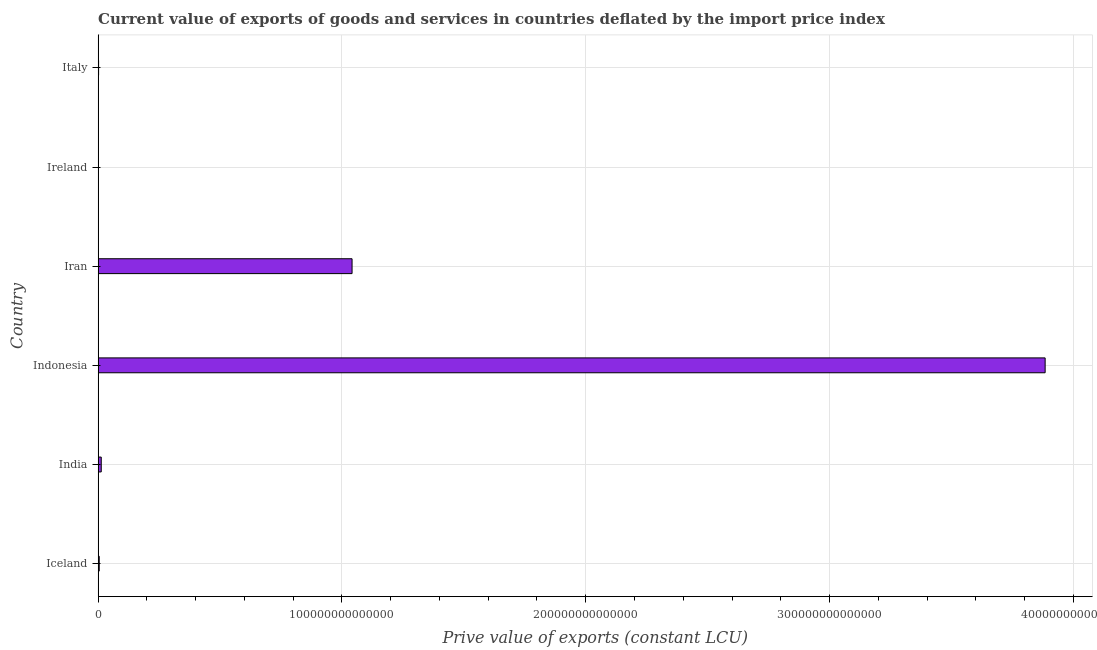What is the title of the graph?
Your answer should be compact. Current value of exports of goods and services in countries deflated by the import price index. What is the label or title of the X-axis?
Keep it short and to the point. Prive value of exports (constant LCU). What is the label or title of the Y-axis?
Your answer should be compact. Country. What is the price value of exports in Italy?
Offer a terse response. 1.94e+11. Across all countries, what is the maximum price value of exports?
Keep it short and to the point. 3.88e+14. Across all countries, what is the minimum price value of exports?
Keep it short and to the point. 2.44e+1. In which country was the price value of exports maximum?
Provide a succinct answer. Indonesia. In which country was the price value of exports minimum?
Keep it short and to the point. Ireland. What is the sum of the price value of exports?
Offer a very short reply. 4.95e+14. What is the difference between the price value of exports in Indonesia and Ireland?
Keep it short and to the point. 3.88e+14. What is the average price value of exports per country?
Make the answer very short. 8.24e+13. What is the median price value of exports?
Provide a succinct answer. 8.71e+11. In how many countries, is the price value of exports greater than 80000000000000 LCU?
Provide a short and direct response. 2. What is the ratio of the price value of exports in Iceland to that in Italy?
Your answer should be very brief. 2.36. Is the difference between the price value of exports in India and Ireland greater than the difference between any two countries?
Provide a succinct answer. No. What is the difference between the highest and the second highest price value of exports?
Make the answer very short. 2.84e+14. What is the difference between the highest and the lowest price value of exports?
Your response must be concise. 3.88e+14. In how many countries, is the price value of exports greater than the average price value of exports taken over all countries?
Provide a short and direct response. 2. How many countries are there in the graph?
Your answer should be compact. 6. What is the difference between two consecutive major ticks on the X-axis?
Your answer should be very brief. 1.00e+14. What is the Prive value of exports (constant LCU) in Iceland?
Give a very brief answer. 4.57e+11. What is the Prive value of exports (constant LCU) of India?
Give a very brief answer. 1.28e+12. What is the Prive value of exports (constant LCU) of Indonesia?
Ensure brevity in your answer.  3.88e+14. What is the Prive value of exports (constant LCU) in Iran?
Ensure brevity in your answer.  1.04e+14. What is the Prive value of exports (constant LCU) in Ireland?
Provide a short and direct response. 2.44e+1. What is the Prive value of exports (constant LCU) in Italy?
Offer a terse response. 1.94e+11. What is the difference between the Prive value of exports (constant LCU) in Iceland and India?
Provide a succinct answer. -8.27e+11. What is the difference between the Prive value of exports (constant LCU) in Iceland and Indonesia?
Offer a terse response. -3.88e+14. What is the difference between the Prive value of exports (constant LCU) in Iceland and Iran?
Ensure brevity in your answer.  -1.04e+14. What is the difference between the Prive value of exports (constant LCU) in Iceland and Ireland?
Your answer should be very brief. 4.33e+11. What is the difference between the Prive value of exports (constant LCU) in Iceland and Italy?
Your answer should be compact. 2.63e+11. What is the difference between the Prive value of exports (constant LCU) in India and Indonesia?
Provide a short and direct response. -3.87e+14. What is the difference between the Prive value of exports (constant LCU) in India and Iran?
Offer a terse response. -1.03e+14. What is the difference between the Prive value of exports (constant LCU) in India and Ireland?
Ensure brevity in your answer.  1.26e+12. What is the difference between the Prive value of exports (constant LCU) in India and Italy?
Offer a terse response. 1.09e+12. What is the difference between the Prive value of exports (constant LCU) in Indonesia and Iran?
Make the answer very short. 2.84e+14. What is the difference between the Prive value of exports (constant LCU) in Indonesia and Ireland?
Keep it short and to the point. 3.88e+14. What is the difference between the Prive value of exports (constant LCU) in Indonesia and Italy?
Offer a very short reply. 3.88e+14. What is the difference between the Prive value of exports (constant LCU) in Iran and Ireland?
Provide a succinct answer. 1.04e+14. What is the difference between the Prive value of exports (constant LCU) in Iran and Italy?
Make the answer very short. 1.04e+14. What is the difference between the Prive value of exports (constant LCU) in Ireland and Italy?
Offer a very short reply. -1.70e+11. What is the ratio of the Prive value of exports (constant LCU) in Iceland to that in India?
Offer a very short reply. 0.36. What is the ratio of the Prive value of exports (constant LCU) in Iceland to that in Iran?
Keep it short and to the point. 0. What is the ratio of the Prive value of exports (constant LCU) in Iceland to that in Ireland?
Your answer should be compact. 18.71. What is the ratio of the Prive value of exports (constant LCU) in Iceland to that in Italy?
Offer a very short reply. 2.36. What is the ratio of the Prive value of exports (constant LCU) in India to that in Indonesia?
Make the answer very short. 0. What is the ratio of the Prive value of exports (constant LCU) in India to that in Iran?
Give a very brief answer. 0.01. What is the ratio of the Prive value of exports (constant LCU) in India to that in Ireland?
Your answer should be compact. 52.55. What is the ratio of the Prive value of exports (constant LCU) in India to that in Italy?
Provide a short and direct response. 6.62. What is the ratio of the Prive value of exports (constant LCU) in Indonesia to that in Iran?
Offer a very short reply. 3.73. What is the ratio of the Prive value of exports (constant LCU) in Indonesia to that in Ireland?
Your answer should be compact. 1.59e+04. What is the ratio of the Prive value of exports (constant LCU) in Indonesia to that in Italy?
Ensure brevity in your answer.  2002.87. What is the ratio of the Prive value of exports (constant LCU) in Iran to that in Ireland?
Your answer should be very brief. 4262.27. What is the ratio of the Prive value of exports (constant LCU) in Iran to that in Italy?
Offer a very short reply. 537.08. What is the ratio of the Prive value of exports (constant LCU) in Ireland to that in Italy?
Ensure brevity in your answer.  0.13. 